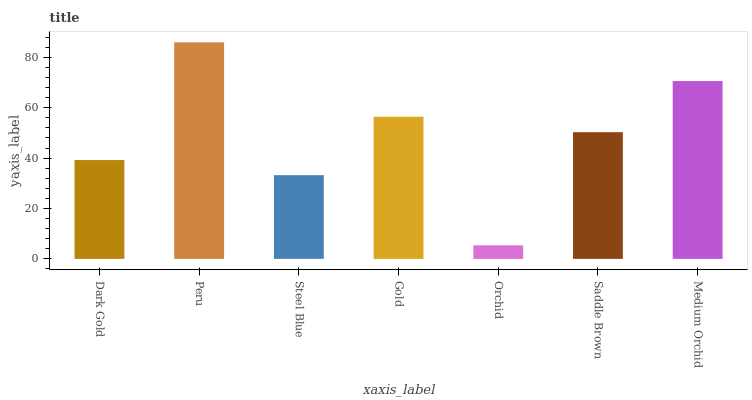Is Orchid the minimum?
Answer yes or no. Yes. Is Peru the maximum?
Answer yes or no. Yes. Is Steel Blue the minimum?
Answer yes or no. No. Is Steel Blue the maximum?
Answer yes or no. No. Is Peru greater than Steel Blue?
Answer yes or no. Yes. Is Steel Blue less than Peru?
Answer yes or no. Yes. Is Steel Blue greater than Peru?
Answer yes or no. No. Is Peru less than Steel Blue?
Answer yes or no. No. Is Saddle Brown the high median?
Answer yes or no. Yes. Is Saddle Brown the low median?
Answer yes or no. Yes. Is Medium Orchid the high median?
Answer yes or no. No. Is Gold the low median?
Answer yes or no. No. 